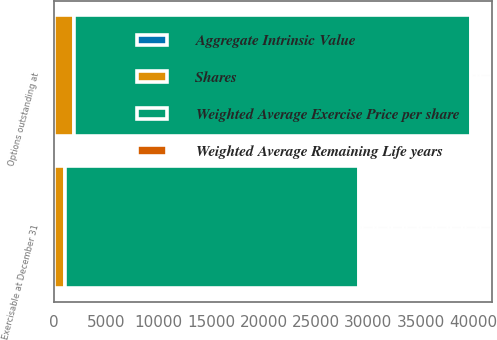<chart> <loc_0><loc_0><loc_500><loc_500><stacked_bar_chart><ecel><fcel>Options outstanding at<fcel>Exercisable at December 31<nl><fcel>Shares<fcel>1910<fcel>1094<nl><fcel>Weighted Average Remaining Life years<fcel>33.47<fcel>27.68<nl><fcel>Aggregate Intrinsic Value<fcel>3.9<fcel>2.8<nl><fcel>Weighted Average Exercise Price per share<fcel>37881<fcel>28022<nl></chart> 